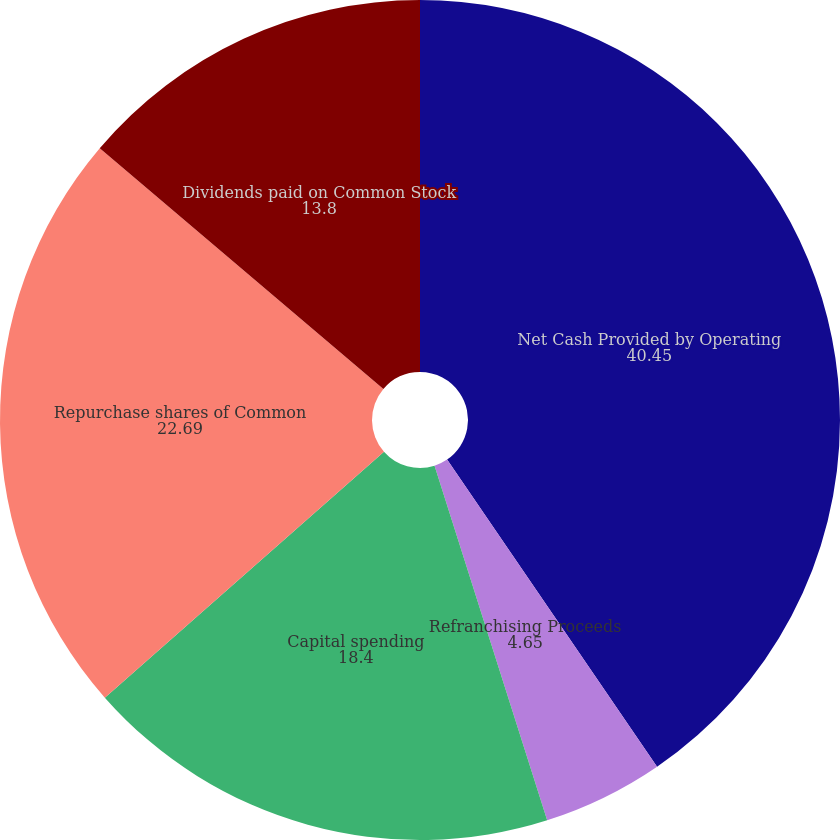Convert chart to OTSL. <chart><loc_0><loc_0><loc_500><loc_500><pie_chart><fcel>Net Cash Provided by Operating<fcel>Refranchising Proceeds<fcel>Capital spending<fcel>Repurchase shares of Common<fcel>Dividends paid on Common Stock<nl><fcel>40.45%<fcel>4.65%<fcel>18.4%<fcel>22.69%<fcel>13.8%<nl></chart> 